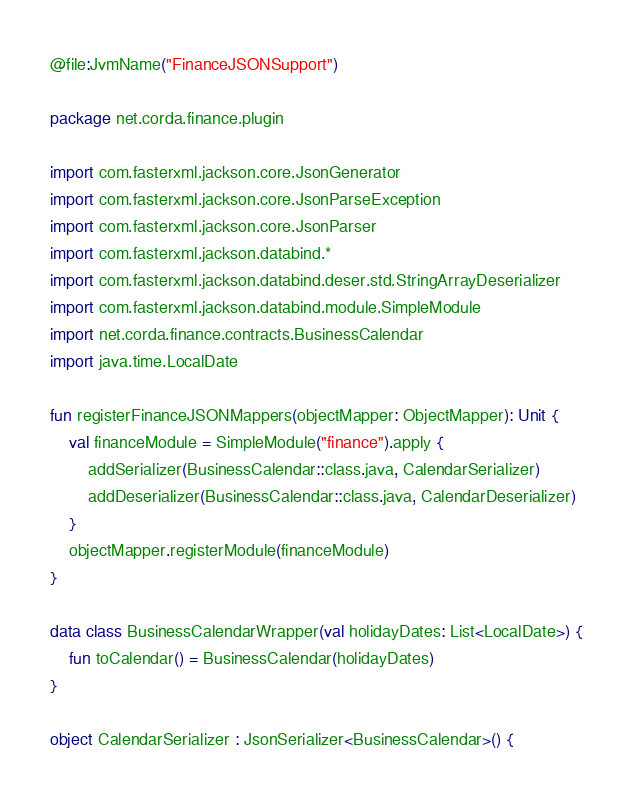Convert code to text. <code><loc_0><loc_0><loc_500><loc_500><_Kotlin_>@file:JvmName("FinanceJSONSupport")

package net.corda.finance.plugin

import com.fasterxml.jackson.core.JsonGenerator
import com.fasterxml.jackson.core.JsonParseException
import com.fasterxml.jackson.core.JsonParser
import com.fasterxml.jackson.databind.*
import com.fasterxml.jackson.databind.deser.std.StringArrayDeserializer
import com.fasterxml.jackson.databind.module.SimpleModule
import net.corda.finance.contracts.BusinessCalendar
import java.time.LocalDate

fun registerFinanceJSONMappers(objectMapper: ObjectMapper): Unit {
    val financeModule = SimpleModule("finance").apply {
        addSerializer(BusinessCalendar::class.java, CalendarSerializer)
        addDeserializer(BusinessCalendar::class.java, CalendarDeserializer)
    }
    objectMapper.registerModule(financeModule)
}

data class BusinessCalendarWrapper(val holidayDates: List<LocalDate>) {
    fun toCalendar() = BusinessCalendar(holidayDates)
}

object CalendarSerializer : JsonSerializer<BusinessCalendar>() {</code> 